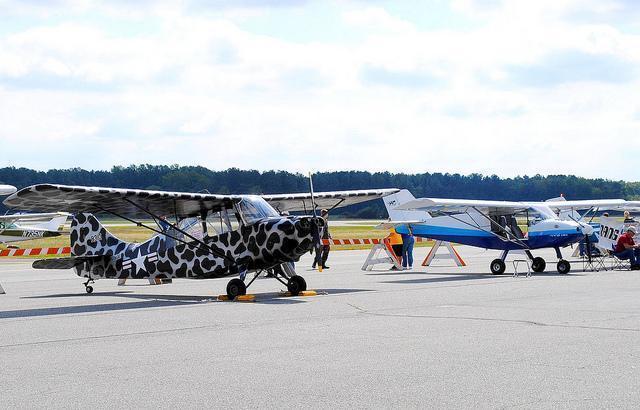What animal mimics the pattern of the plane to the left?
Answer the question by selecting the correct answer among the 4 following choices and explain your choice with a short sentence. The answer should be formatted with the following format: `Answer: choice
Rationale: rationale.`
Options: Cheetah, snow leopard, frog, dog. Answer: snow leopard.
Rationale: The animal is a leopard. 